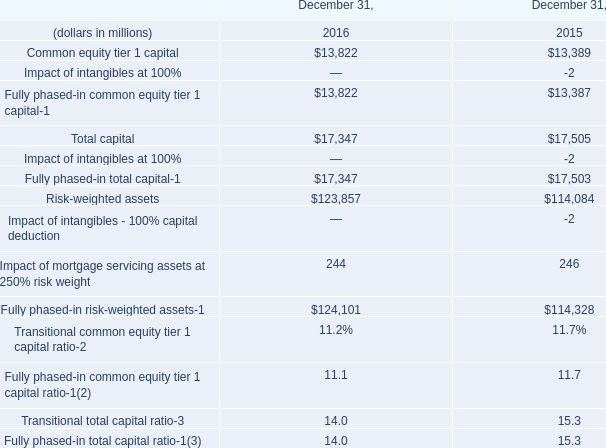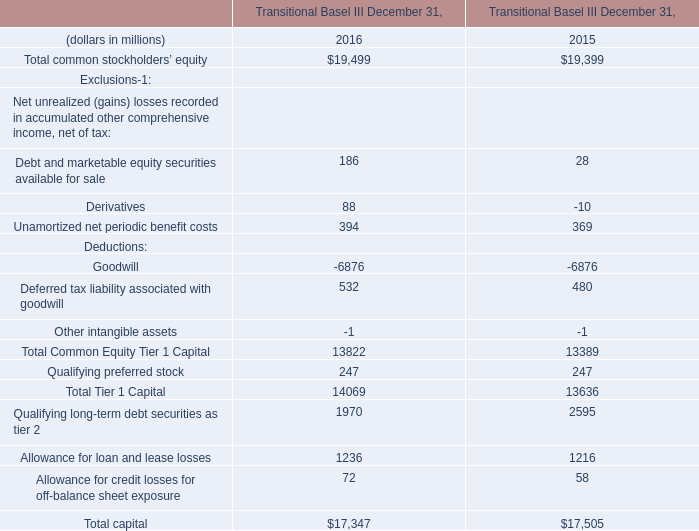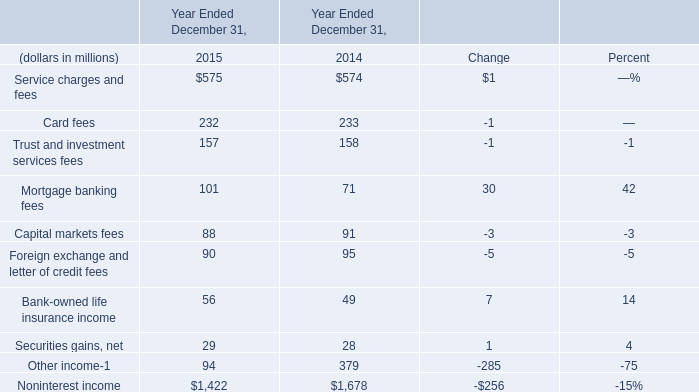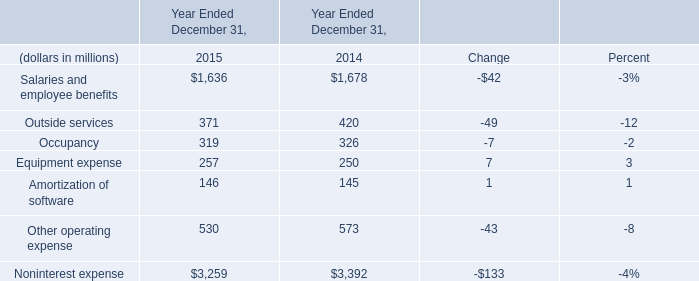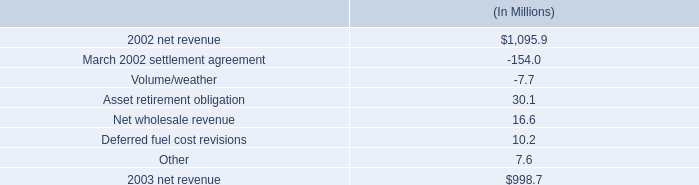What was the total amount of the Noninterest income in the years where Mortgage banking fees is greater than 100? (in million) 
Answer: 1422. 